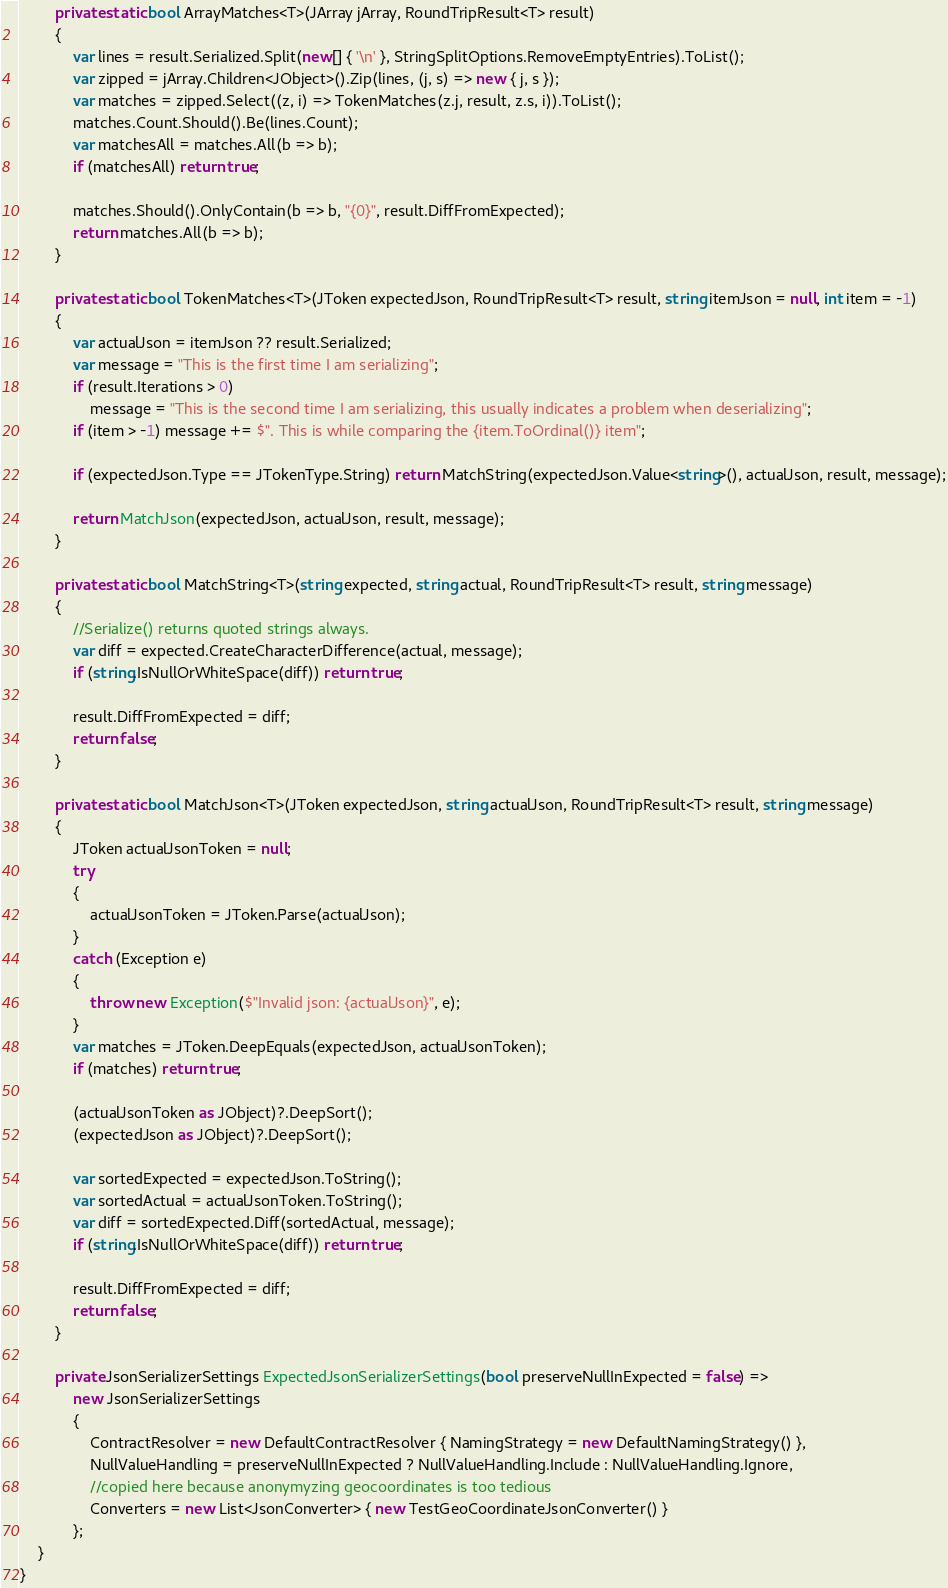Convert code to text. <code><loc_0><loc_0><loc_500><loc_500><_C#_>		private static bool ArrayMatches<T>(JArray jArray, RoundTripResult<T> result)
		{
			var lines = result.Serialized.Split(new[] { '\n' }, StringSplitOptions.RemoveEmptyEntries).ToList();
			var zipped = jArray.Children<JObject>().Zip(lines, (j, s) => new { j, s });
			var matches = zipped.Select((z, i) => TokenMatches(z.j, result, z.s, i)).ToList();
			matches.Count.Should().Be(lines.Count);
			var matchesAll = matches.All(b => b);
			if (matchesAll) return true;

			matches.Should().OnlyContain(b => b, "{0}", result.DiffFromExpected);
			return matches.All(b => b);
		}

		private static bool TokenMatches<T>(JToken expectedJson, RoundTripResult<T> result, string itemJson = null, int item = -1)
		{
			var actualJson = itemJson ?? result.Serialized;
			var message = "This is the first time I am serializing";
			if (result.Iterations > 0)
				message = "This is the second time I am serializing, this usually indicates a problem when deserializing";
			if (item > -1) message += $". This is while comparing the {item.ToOrdinal()} item";

			if (expectedJson.Type == JTokenType.String) return MatchString(expectedJson.Value<string>(), actualJson, result, message);

			return MatchJson(expectedJson, actualJson, result, message);
		}

		private static bool MatchString<T>(string expected, string actual, RoundTripResult<T> result, string message)
		{
			//Serialize() returns quoted strings always.
			var diff = expected.CreateCharacterDifference(actual, message);
			if (string.IsNullOrWhiteSpace(diff)) return true;

			result.DiffFromExpected = diff;
			return false;
		}

		private static bool MatchJson<T>(JToken expectedJson, string actualJson, RoundTripResult<T> result, string message)
		{
			JToken actualJsonToken = null;
			try
			{
				actualJsonToken = JToken.Parse(actualJson);
			}
			catch (Exception e)
			{
				throw new Exception($"Invalid json: {actualJson}", e);
			}
			var matches = JToken.DeepEquals(expectedJson, actualJsonToken);
			if (matches) return true;

			(actualJsonToken as JObject)?.DeepSort();
			(expectedJson as JObject)?.DeepSort();

			var sortedExpected = expectedJson.ToString();
			var sortedActual = actualJsonToken.ToString();
			var diff = sortedExpected.Diff(sortedActual, message);
			if (string.IsNullOrWhiteSpace(diff)) return true;

			result.DiffFromExpected = diff;
			return false;
		}

		private JsonSerializerSettings ExpectedJsonSerializerSettings(bool preserveNullInExpected = false) =>
			new JsonSerializerSettings
			{
				ContractResolver = new DefaultContractResolver { NamingStrategy = new DefaultNamingStrategy() },
				NullValueHandling = preserveNullInExpected ? NullValueHandling.Include : NullValueHandling.Ignore,
				//copied here because anonymyzing geocoordinates is too tedious
				Converters = new List<JsonConverter> { new TestGeoCoordinateJsonConverter() }
			};
	}
}
</code> 